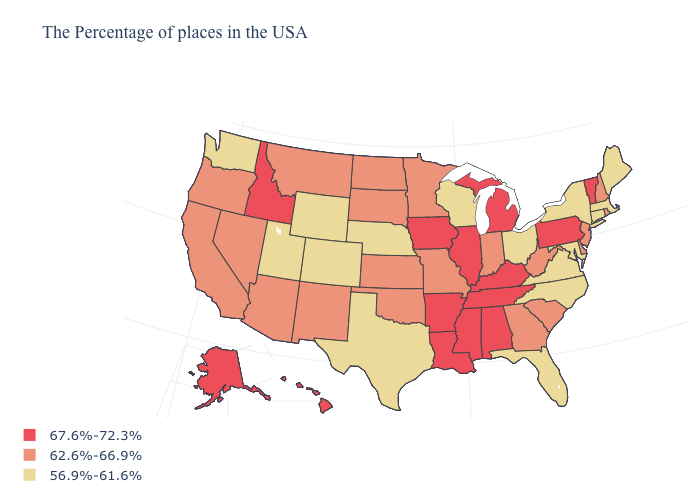What is the highest value in states that border Georgia?
Answer briefly. 67.6%-72.3%. What is the value of Nevada?
Quick response, please. 62.6%-66.9%. Name the states that have a value in the range 62.6%-66.9%?
Answer briefly. Rhode Island, New Hampshire, New Jersey, Delaware, South Carolina, West Virginia, Georgia, Indiana, Missouri, Minnesota, Kansas, Oklahoma, South Dakota, North Dakota, New Mexico, Montana, Arizona, Nevada, California, Oregon. What is the value of Pennsylvania?
Be succinct. 67.6%-72.3%. Does the map have missing data?
Give a very brief answer. No. What is the highest value in states that border Delaware?
Keep it brief. 67.6%-72.3%. Does the map have missing data?
Answer briefly. No. What is the value of North Carolina?
Be succinct. 56.9%-61.6%. What is the value of Delaware?
Give a very brief answer. 62.6%-66.9%. Among the states that border Colorado , which have the highest value?
Write a very short answer. Kansas, Oklahoma, New Mexico, Arizona. What is the value of Maine?
Short answer required. 56.9%-61.6%. Does the map have missing data?
Be succinct. No. What is the value of New Mexico?
Quick response, please. 62.6%-66.9%. What is the value of Michigan?
Write a very short answer. 67.6%-72.3%. Which states have the lowest value in the West?
Short answer required. Wyoming, Colorado, Utah, Washington. 